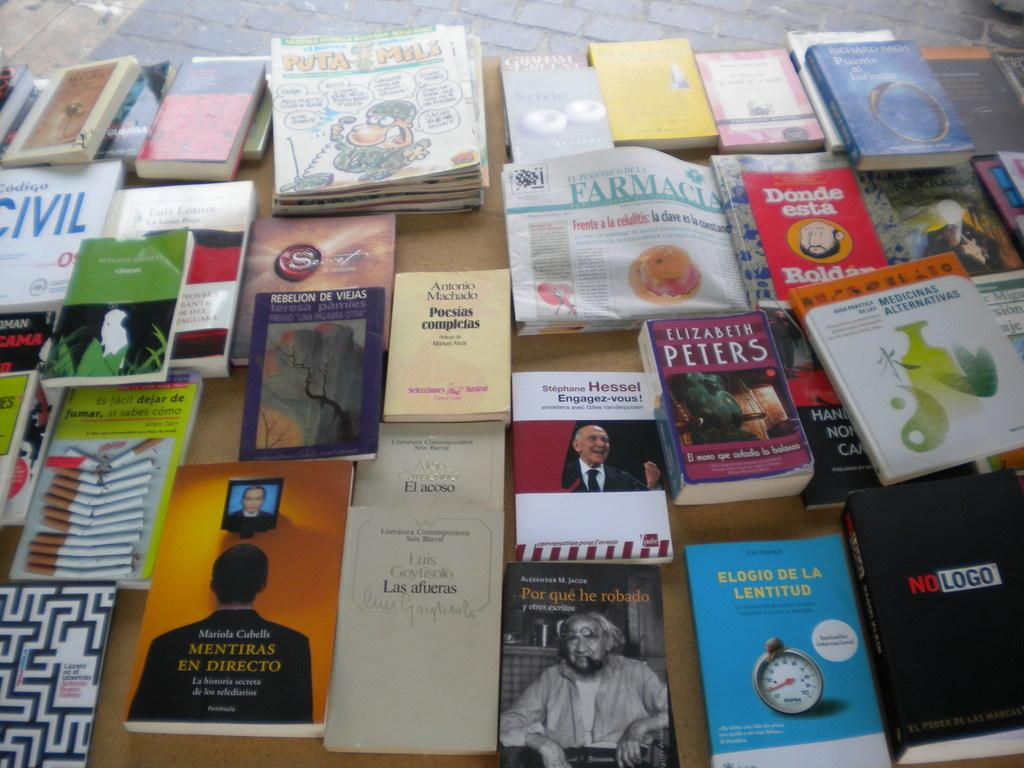<image>
Create a compact narrative representing the image presented. Many books on a table with one by Elizabeth Peters. 